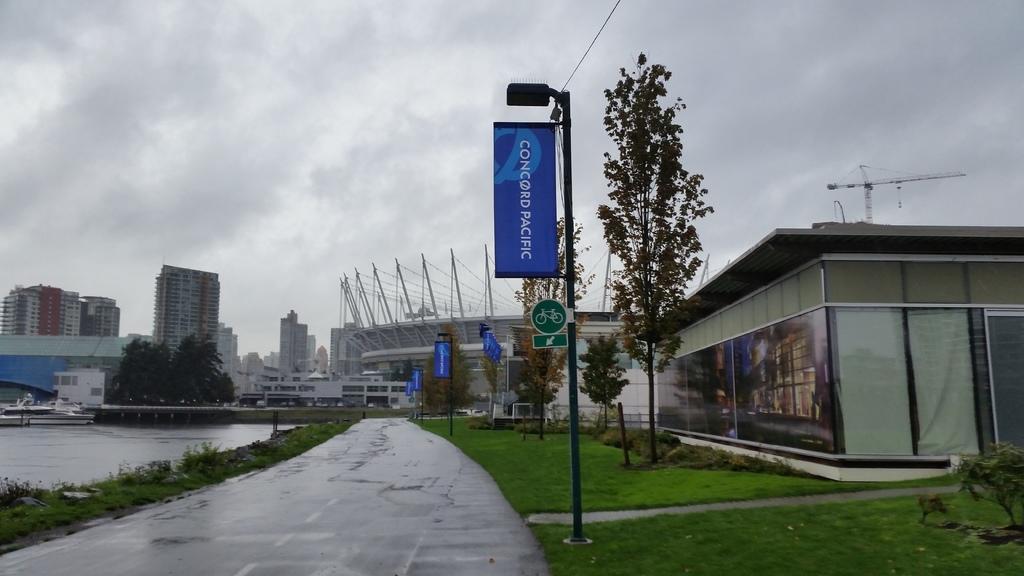Could you give a brief overview of what you see in this image? In this image, there are a few buildings, poles, boards. We can see the ground and some grass. We can also see some plants, trees. We can also see the sky with clouds. We can see some water and some objects. 